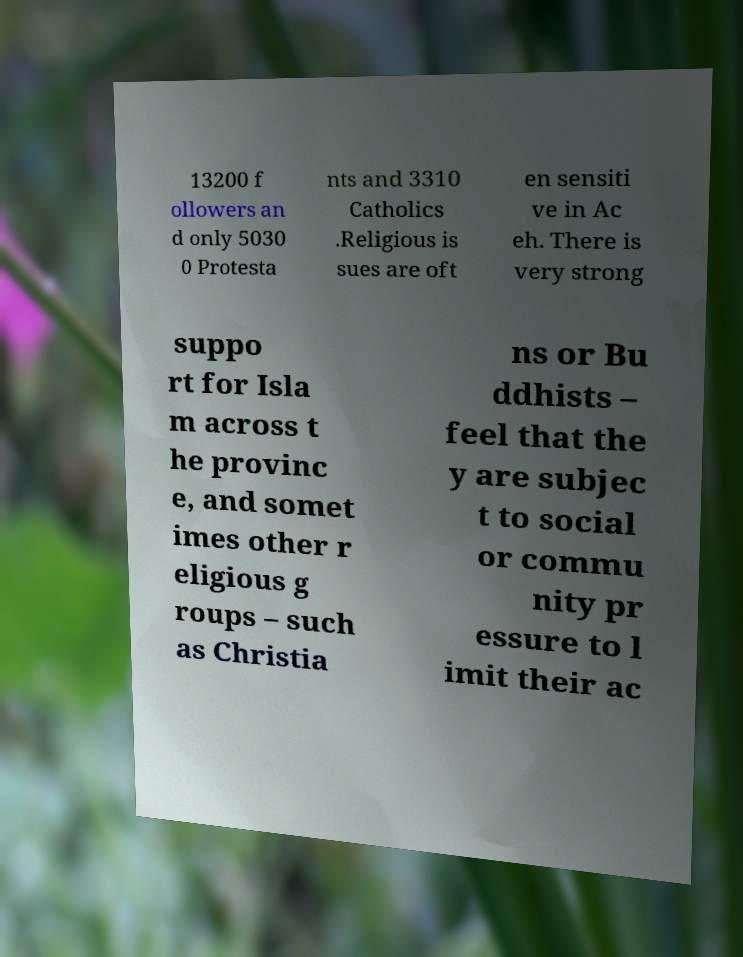I need the written content from this picture converted into text. Can you do that? 13200 f ollowers an d only 5030 0 Protesta nts and 3310 Catholics .Religious is sues are oft en sensiti ve in Ac eh. There is very strong suppo rt for Isla m across t he provinc e, and somet imes other r eligious g roups – such as Christia ns or Bu ddhists – feel that the y are subjec t to social or commu nity pr essure to l imit their ac 